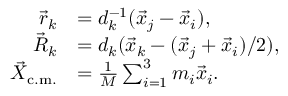Convert formula to latex. <formula><loc_0><loc_0><loc_500><loc_500>\begin{array} { r l } { \vec { r } _ { k } } & { = d _ { k } ^ { - 1 } ( \vec { x } _ { j } - \vec { x } _ { i } ) , } \\ { \vec { R } _ { k } } & { = d _ { k } ( \vec { x } _ { k } - ( \vec { x } _ { j } + \vec { x } _ { i } ) / 2 ) , } \\ { \vec { X } _ { c . m . } } & { = \frac { 1 } { M } \sum _ { i = 1 } ^ { 3 } m _ { i } \vec { x } _ { i } . } \end{array}</formula> 